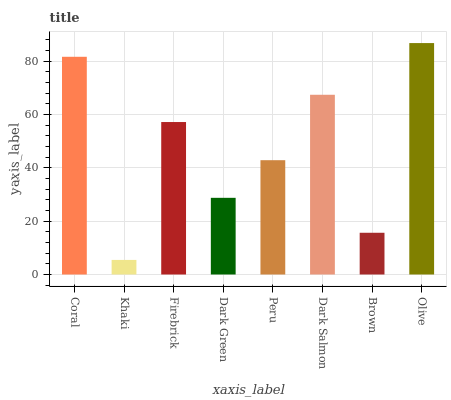Is Khaki the minimum?
Answer yes or no. Yes. Is Olive the maximum?
Answer yes or no. Yes. Is Firebrick the minimum?
Answer yes or no. No. Is Firebrick the maximum?
Answer yes or no. No. Is Firebrick greater than Khaki?
Answer yes or no. Yes. Is Khaki less than Firebrick?
Answer yes or no. Yes. Is Khaki greater than Firebrick?
Answer yes or no. No. Is Firebrick less than Khaki?
Answer yes or no. No. Is Firebrick the high median?
Answer yes or no. Yes. Is Peru the low median?
Answer yes or no. Yes. Is Peru the high median?
Answer yes or no. No. Is Olive the low median?
Answer yes or no. No. 